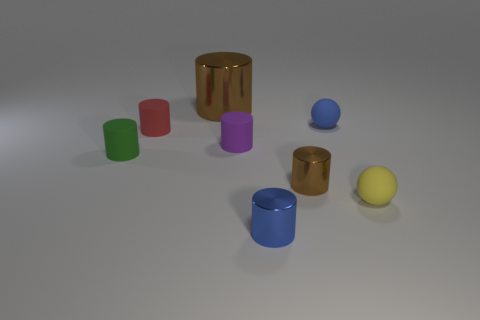Are all the objects made of the same material? While it's a bit difficult to assess without tactile feedback, the visual cues suggest variations. The two cylinders with a shiny finish seem to be metallic, while the others display a matte surface, indicating they could be made of plastic or another non-metallic substance. 